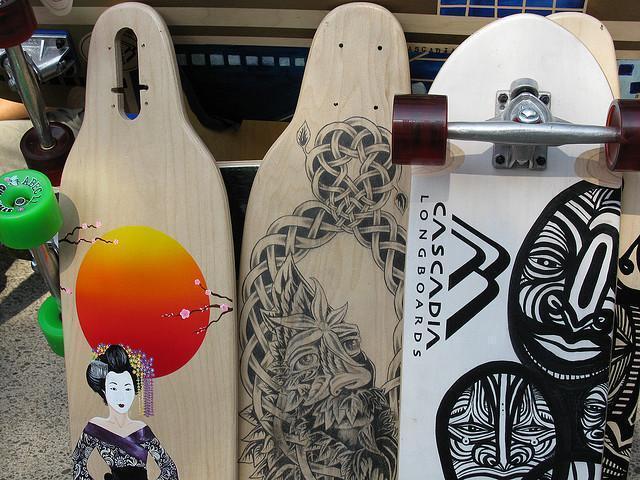This board is used for what sport?
Choose the right answer from the provided options to respond to the question.
Options: Skating, skateboarding, surfing, skiing. Skateboarding. 